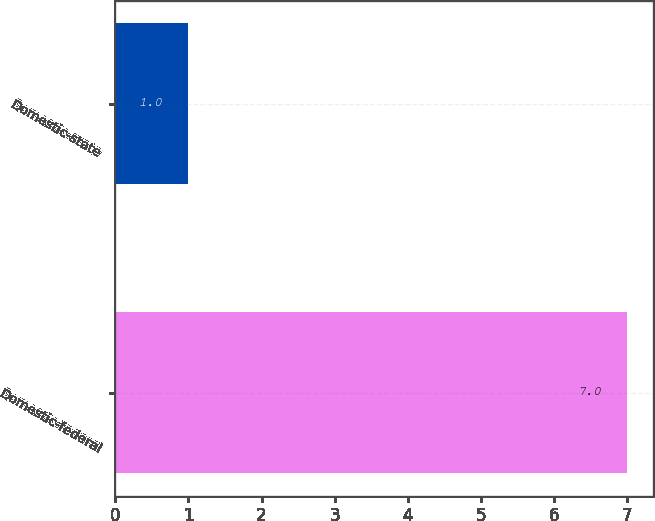<chart> <loc_0><loc_0><loc_500><loc_500><bar_chart><fcel>Domestic-federal<fcel>Domestic-state<nl><fcel>7<fcel>1<nl></chart> 